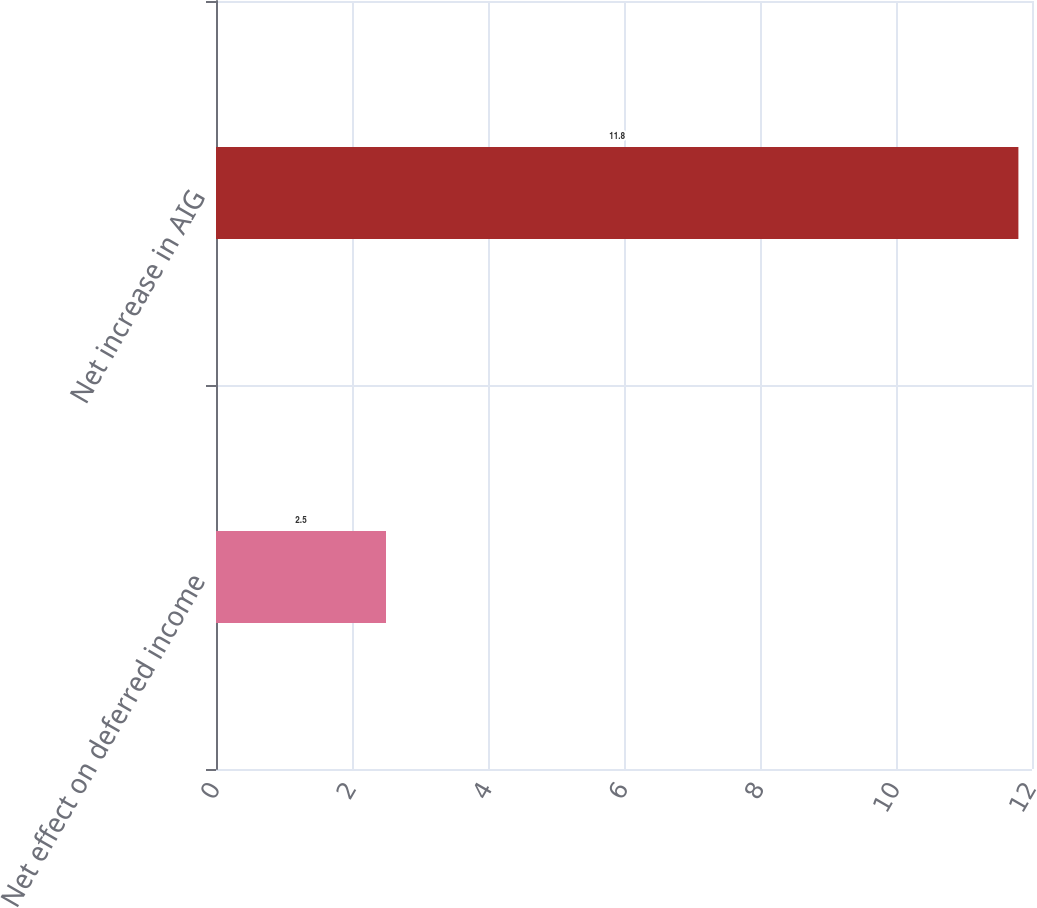<chart> <loc_0><loc_0><loc_500><loc_500><bar_chart><fcel>Net effect on deferred income<fcel>Net increase in AIG<nl><fcel>2.5<fcel>11.8<nl></chart> 